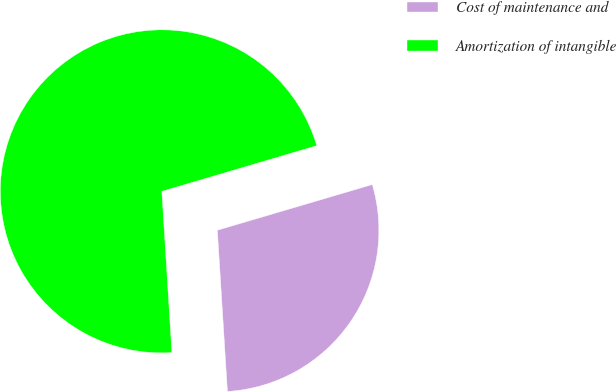Convert chart to OTSL. <chart><loc_0><loc_0><loc_500><loc_500><pie_chart><fcel>Cost of maintenance and<fcel>Amortization of intangible<nl><fcel>28.57%<fcel>71.43%<nl></chart> 